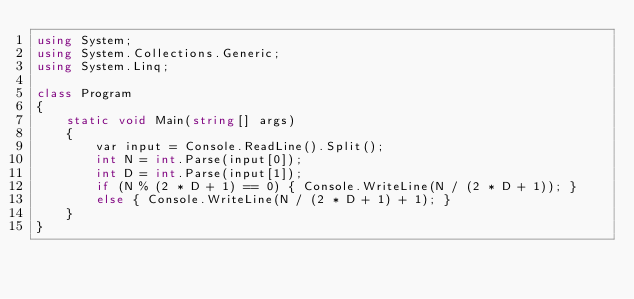Convert code to text. <code><loc_0><loc_0><loc_500><loc_500><_C#_>using System;
using System.Collections.Generic;
using System.Linq;

class Program
{
    static void Main(string[] args)
    {
        var input = Console.ReadLine().Split();
        int N = int.Parse(input[0]);
        int D = int.Parse(input[1]);
        if (N % (2 * D + 1) == 0) { Console.WriteLine(N / (2 * D + 1)); }
        else { Console.WriteLine(N / (2 * D + 1) + 1); }
    }
}
</code> 